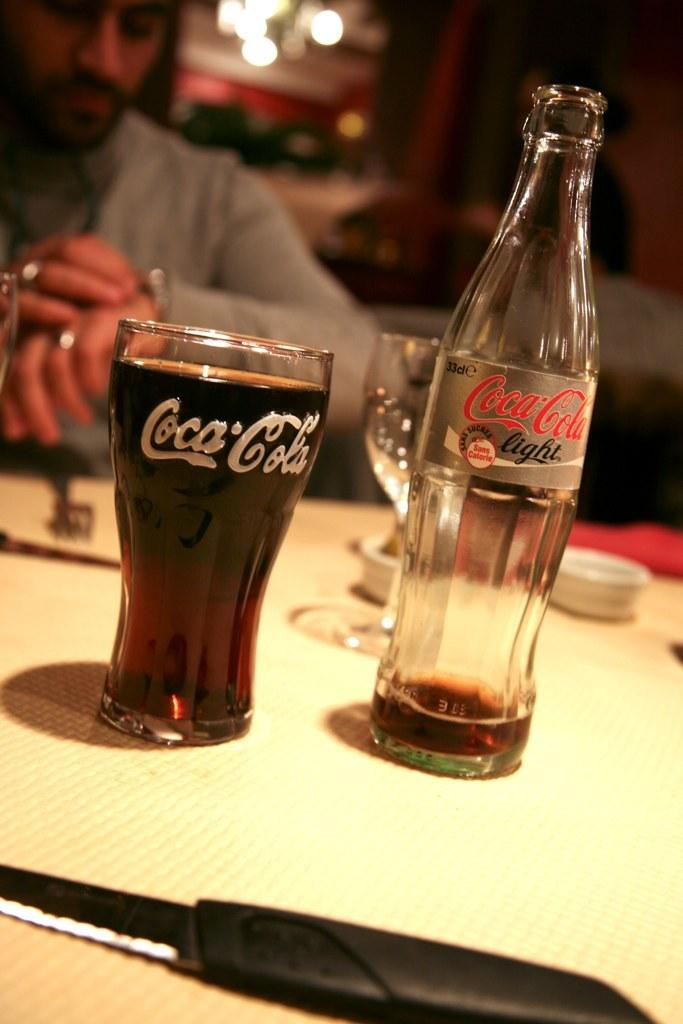<image>
Summarize the visual content of the image. A bottle of Coca-Cola  light sits in front of a man looking at his watch. 